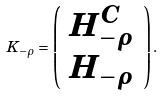<formula> <loc_0><loc_0><loc_500><loc_500>K _ { - \rho } = \left ( \begin{array} { c } H ^ { C } _ { - \rho } \\ H _ { - \rho } \end{array} \right ) .</formula> 